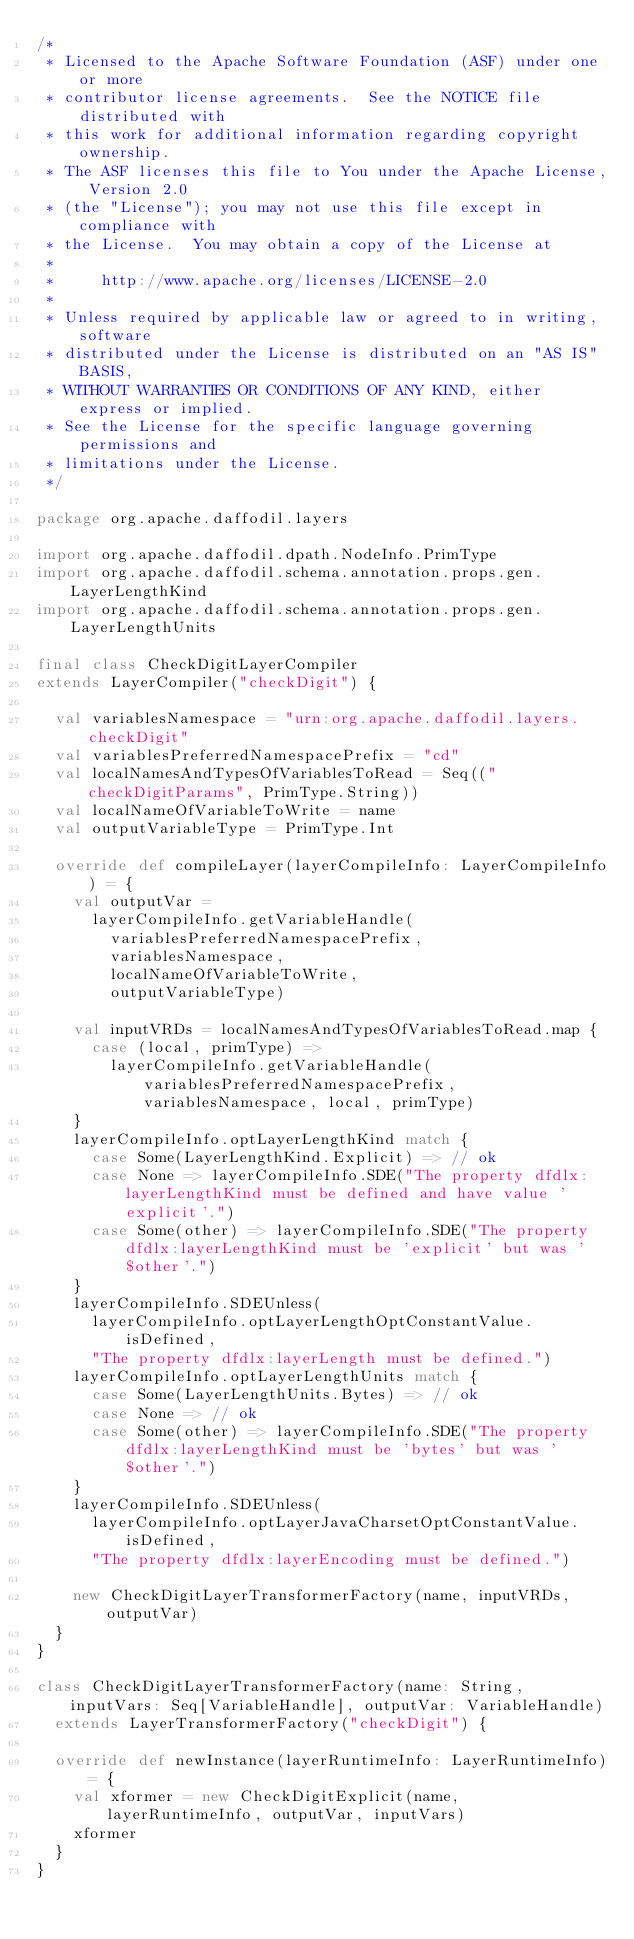Convert code to text. <code><loc_0><loc_0><loc_500><loc_500><_Scala_>/*
 * Licensed to the Apache Software Foundation (ASF) under one or more
 * contributor license agreements.  See the NOTICE file distributed with
 * this work for additional information regarding copyright ownership.
 * The ASF licenses this file to You under the Apache License, Version 2.0
 * (the "License"); you may not use this file except in compliance with
 * the License.  You may obtain a copy of the License at
 *
 *     http://www.apache.org/licenses/LICENSE-2.0
 *
 * Unless required by applicable law or agreed to in writing, software
 * distributed under the License is distributed on an "AS IS" BASIS,
 * WITHOUT WARRANTIES OR CONDITIONS OF ANY KIND, either express or implied.
 * See the License for the specific language governing permissions and
 * limitations under the License.
 */

package org.apache.daffodil.layers

import org.apache.daffodil.dpath.NodeInfo.PrimType
import org.apache.daffodil.schema.annotation.props.gen.LayerLengthKind
import org.apache.daffodil.schema.annotation.props.gen.LayerLengthUnits

final class CheckDigitLayerCompiler
extends LayerCompiler("checkDigit") {

  val variablesNamespace = "urn:org.apache.daffodil.layers.checkDigit"
  val variablesPreferredNamespacePrefix = "cd"
  val localNamesAndTypesOfVariablesToRead = Seq(("checkDigitParams", PrimType.String))
  val localNameOfVariableToWrite = name
  val outputVariableType = PrimType.Int

  override def compileLayer(layerCompileInfo: LayerCompileInfo) = {
    val outputVar =
      layerCompileInfo.getVariableHandle(
        variablesPreferredNamespacePrefix,
        variablesNamespace,
        localNameOfVariableToWrite,
        outputVariableType)

    val inputVRDs = localNamesAndTypesOfVariablesToRead.map {
      case (local, primType) =>
        layerCompileInfo.getVariableHandle(variablesPreferredNamespacePrefix, variablesNamespace, local, primType)
    }
    layerCompileInfo.optLayerLengthKind match {
      case Some(LayerLengthKind.Explicit) => // ok
      case None => layerCompileInfo.SDE("The property dfdlx:layerLengthKind must be defined and have value 'explicit'.")
      case Some(other) => layerCompileInfo.SDE("The property dfdlx:layerLengthKind must be 'explicit' but was '$other'.")
    }
    layerCompileInfo.SDEUnless(
      layerCompileInfo.optLayerLengthOptConstantValue.isDefined,
      "The property dfdlx:layerLength must be defined.")
    layerCompileInfo.optLayerLengthUnits match {
      case Some(LayerLengthUnits.Bytes) => // ok
      case None => // ok
      case Some(other) => layerCompileInfo.SDE("The property dfdlx:layerLengthKind must be 'bytes' but was '$other'.")
    }
    layerCompileInfo.SDEUnless(
      layerCompileInfo.optLayerJavaCharsetOptConstantValue.isDefined,
      "The property dfdlx:layerEncoding must be defined.")

    new CheckDigitLayerTransformerFactory(name, inputVRDs, outputVar)
  }
}

class CheckDigitLayerTransformerFactory(name: String, inputVars: Seq[VariableHandle], outputVar: VariableHandle)
  extends LayerTransformerFactory("checkDigit") {

  override def newInstance(layerRuntimeInfo: LayerRuntimeInfo)= {
    val xformer = new CheckDigitExplicit(name, layerRuntimeInfo, outputVar, inputVars)
    xformer
  }
}


</code> 